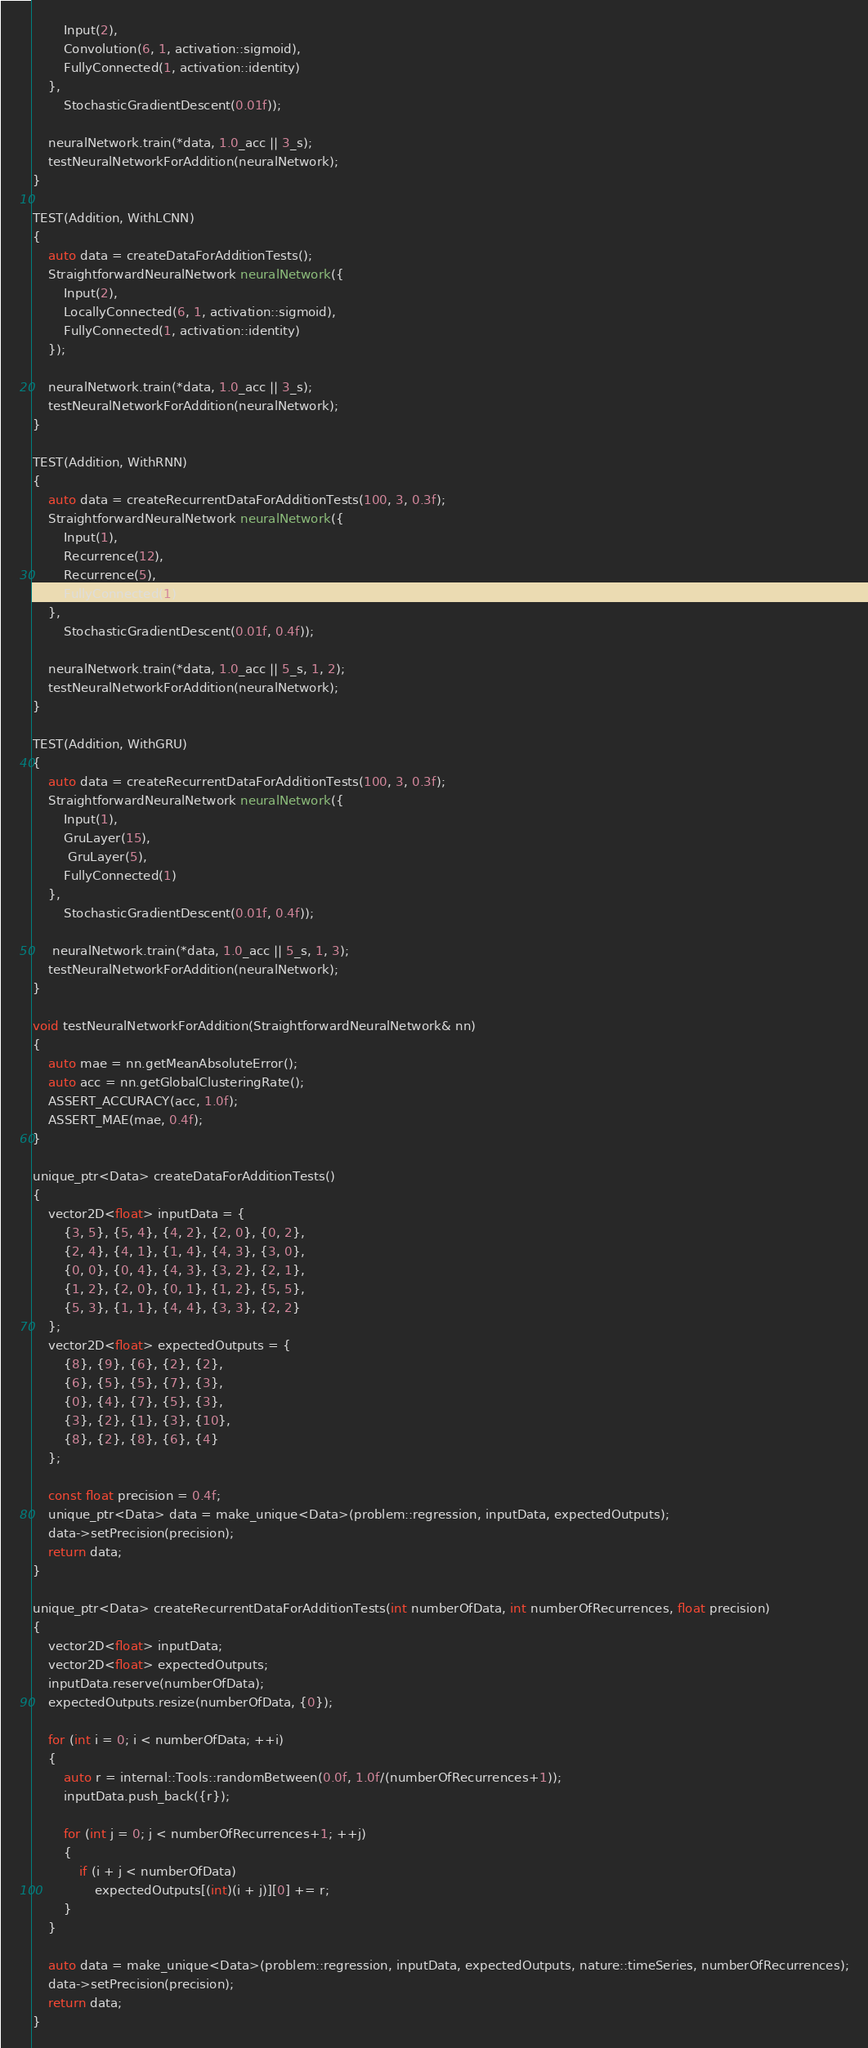<code> <loc_0><loc_0><loc_500><loc_500><_C++_>        Input(2),
        Convolution(6, 1, activation::sigmoid),
        FullyConnected(1, activation::identity)
    }, 
        StochasticGradientDescent(0.01f));

    neuralNetwork.train(*data, 1.0_acc || 3_s);
    testNeuralNetworkForAddition(neuralNetwork);
}

TEST(Addition, WithLCNN)
{
    auto data = createDataForAdditionTests();
    StraightforwardNeuralNetwork neuralNetwork({
        Input(2),
        LocallyConnected(6, 1, activation::sigmoid),
        FullyConnected(1, activation::identity)
    });

    neuralNetwork.train(*data, 1.0_acc || 3_s);
    testNeuralNetworkForAddition(neuralNetwork);
}

TEST(Addition, WithRNN)
{
    auto data = createRecurrentDataForAdditionTests(100, 3, 0.3f);
    StraightforwardNeuralNetwork neuralNetwork({
        Input(1),
        Recurrence(12),
        Recurrence(5),
        FullyConnected(1)
    }, 
        StochasticGradientDescent(0.01f, 0.4f));

    neuralNetwork.train(*data, 1.0_acc || 5_s, 1, 2);
    testNeuralNetworkForAddition(neuralNetwork);
}

TEST(Addition, WithGRU)
{
    auto data = createRecurrentDataForAdditionTests(100, 3, 0.3f);
    StraightforwardNeuralNetwork neuralNetwork({
        Input(1),
        GruLayer(15),
         GruLayer(5),
        FullyConnected(1)
    }, 
        StochasticGradientDescent(0.01f, 0.4f));

     neuralNetwork.train(*data, 1.0_acc || 5_s, 1, 3);
    testNeuralNetworkForAddition(neuralNetwork);
}

void testNeuralNetworkForAddition(StraightforwardNeuralNetwork& nn)
{
    auto mae = nn.getMeanAbsoluteError();
    auto acc = nn.getGlobalClusteringRate();
    ASSERT_ACCURACY(acc, 1.0f);
    ASSERT_MAE(mae, 0.4f);
}

unique_ptr<Data> createDataForAdditionTests()
{
    vector2D<float> inputData = {
        {3, 5}, {5, 4}, {4, 2}, {2, 0}, {0, 2},
        {2, 4}, {4, 1}, {1, 4}, {4, 3}, {3, 0},
        {0, 0}, {0, 4}, {4, 3}, {3, 2}, {2, 1},
        {1, 2}, {2, 0}, {0, 1}, {1, 2}, {5, 5},
        {5, 3}, {1, 1}, {4, 4}, {3, 3}, {2, 2}
    };
    vector2D<float> expectedOutputs = {
        {8}, {9}, {6}, {2}, {2},
        {6}, {5}, {5}, {7}, {3},
        {0}, {4}, {7}, {5}, {3},
        {3}, {2}, {1}, {3}, {10},
        {8}, {2}, {8}, {6}, {4}
    };

    const float precision = 0.4f;
    unique_ptr<Data> data = make_unique<Data>(problem::regression, inputData, expectedOutputs);
    data->setPrecision(precision);
    return data;
}

unique_ptr<Data> createRecurrentDataForAdditionTests(int numberOfData, int numberOfRecurrences, float precision)
{
    vector2D<float> inputData;
    vector2D<float> expectedOutputs;
    inputData.reserve(numberOfData);
    expectedOutputs.resize(numberOfData, {0});

    for (int i = 0; i < numberOfData; ++i)
    {
        auto r = internal::Tools::randomBetween(0.0f, 1.0f/(numberOfRecurrences+1));
        inputData.push_back({r});

        for (int j = 0; j < numberOfRecurrences+1; ++j)
        {
            if (i + j < numberOfData)
                expectedOutputs[(int)(i + j)][0] += r;
        }
    }

    auto data = make_unique<Data>(problem::regression, inputData, expectedOutputs, nature::timeSeries, numberOfRecurrences);
    data->setPrecision(precision);
    return data;
}
</code> 